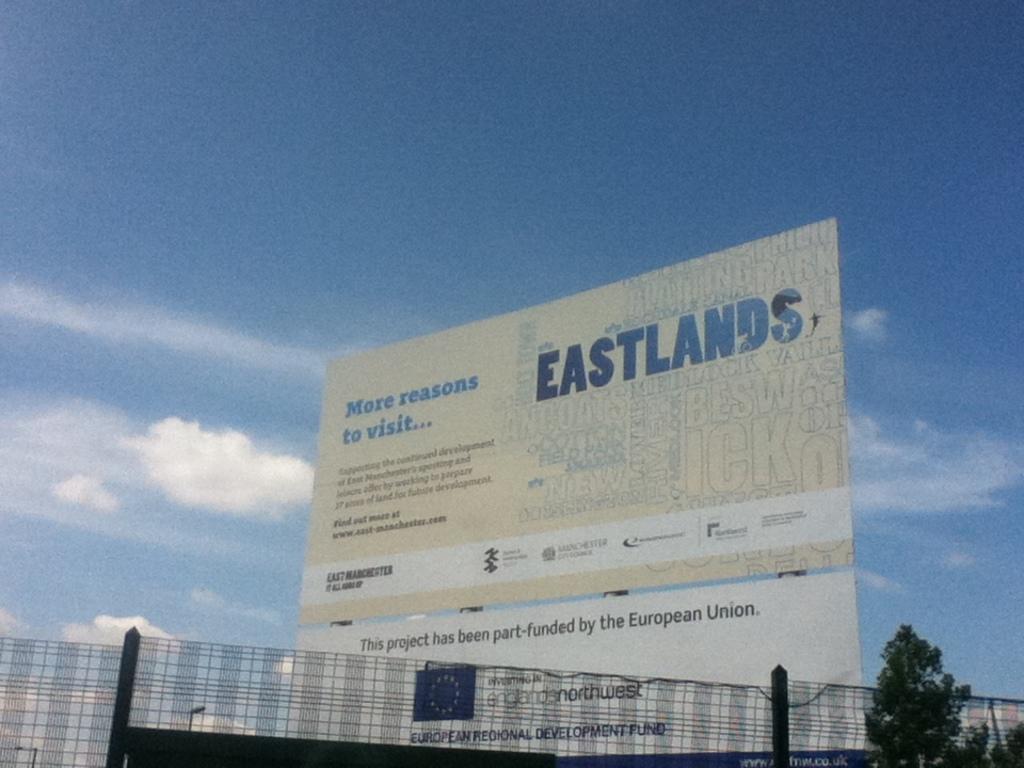What has been part funded by the european union?
Ensure brevity in your answer.  Eastlands. What is this billboard trying to get you to visit?
Ensure brevity in your answer.  Eastlands. 